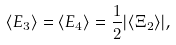<formula> <loc_0><loc_0><loc_500><loc_500>\langle E _ { 3 } \rangle = \langle E _ { 4 } \rangle = \frac { 1 } { 2 } | \langle \Xi _ { 2 } \rangle | ,</formula> 